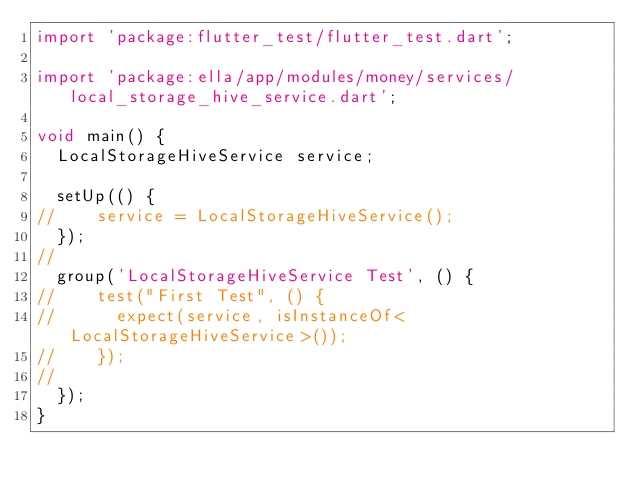Convert code to text. <code><loc_0><loc_0><loc_500><loc_500><_Dart_>import 'package:flutter_test/flutter_test.dart';

import 'package:ella/app/modules/money/services/local_storage_hive_service.dart';

void main() {
  LocalStorageHiveService service;

  setUp(() {
//    service = LocalStorageHiveService();
  });
//
  group('LocalStorageHiveService Test', () {
//    test("First Test", () {
//      expect(service, isInstanceOf<LocalStorageHiveService>());
//    });
//
  });
}
</code> 